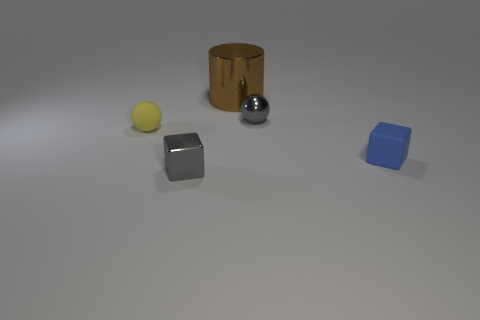Do the brown metal thing and the blue object have the same shape?
Give a very brief answer. No. There is a matte cube that is the same size as the gray metallic sphere; what color is it?
Your response must be concise. Blue. There is a gray thing that is the same shape as the blue thing; what is its size?
Provide a short and direct response. Small. There is a tiny gray thing behind the tiny blue rubber block; what is its shape?
Offer a very short reply. Sphere. Do the tiny yellow rubber object and the tiny gray metal object behind the small blue rubber cube have the same shape?
Offer a terse response. Yes. Are there the same number of gray things that are left of the tiny yellow object and tiny rubber objects left of the small blue object?
Your response must be concise. No. What shape is the tiny object that is the same color as the metal ball?
Give a very brief answer. Cube. Is the color of the block on the left side of the large brown shiny thing the same as the small metal object behind the tiny blue matte block?
Give a very brief answer. Yes. Is the number of objects behind the yellow thing greater than the number of yellow things?
Ensure brevity in your answer.  Yes. What is the material of the small yellow object?
Provide a short and direct response. Rubber. 